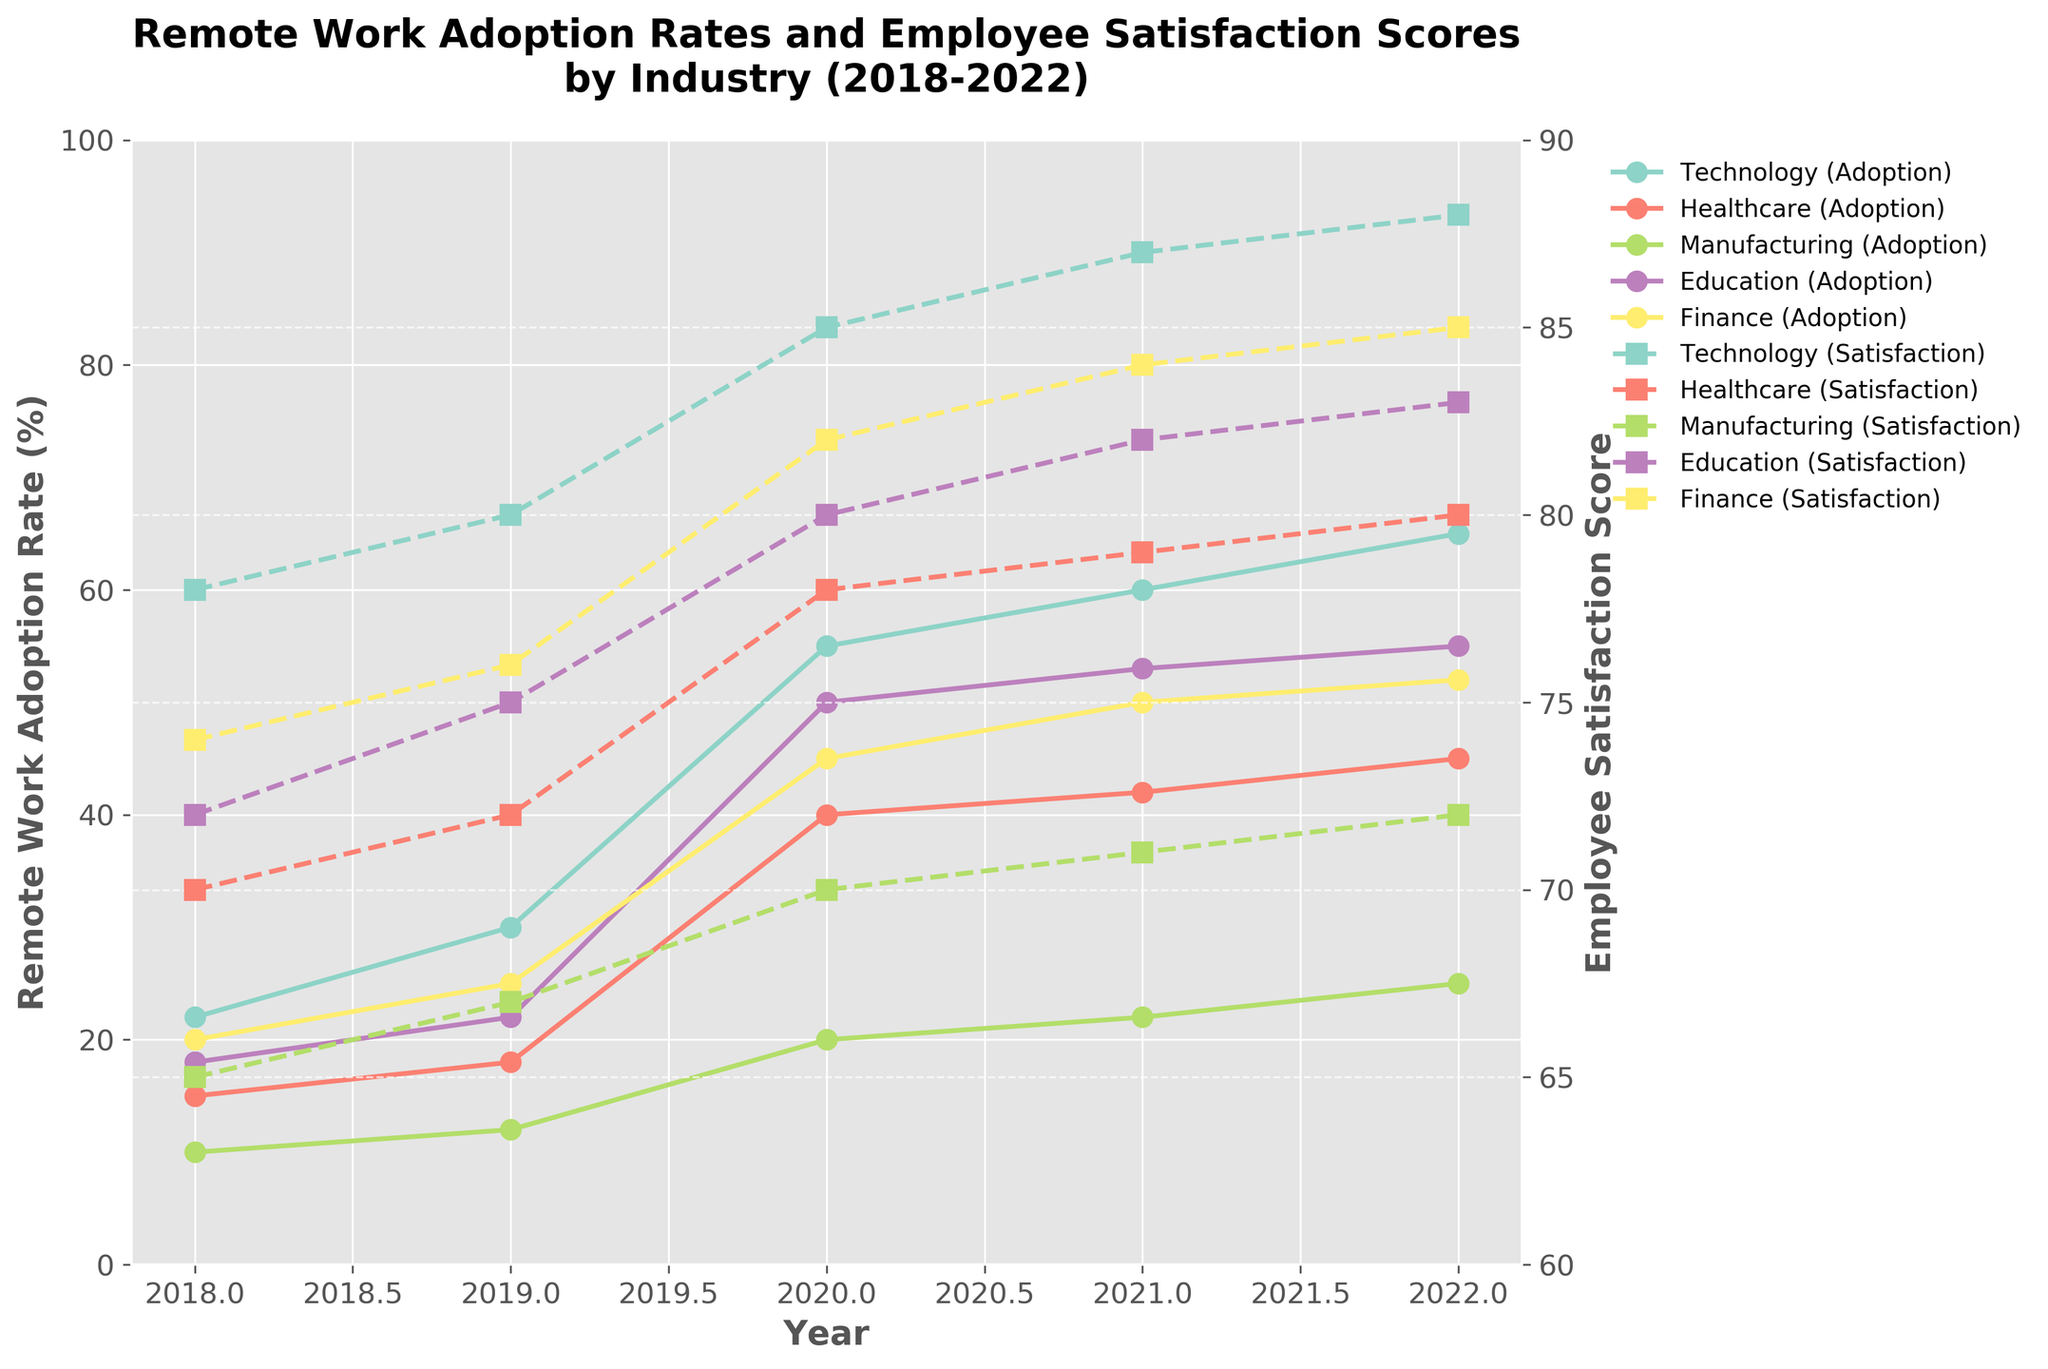What is the trend of remote work adoption in the Technology industry from 2018 to 2022? As we observe the plot, the remote work adoption rate in the Technology industry increases every year from 22% in 2018 to 65% in 2022.
Answer: Increasing What is the highest employee satisfaction score recorded, and in which industry and year did it occur? The highest employee satisfaction score on the plot is 88, recorded in the Technology industry in the year 2022.
Answer: 88, Technology, 2022 Which industry had the lowest remote work adoption rate in 2020? By examining the remote work adoption rates for 2020, it is evident that the Manufacturing industry had the lowest adoption rate of 20%.
Answer: Manufacturing How does the employee satisfaction score for the Healthcare industry in 2021 compare to that in 2019? In 2021, the Healthcare industry had a satisfaction score of 79, while in 2019 it was 72, indicating an increase of 7 points.
Answer: Increased by 7 points Compare the remote work adoption rate and employee satisfaction score for the Finance industry between 2018 and 2022. The remote work adoption in the Finance industry increased from 20% in 2018 to 52% in 2022, and the employee satisfaction score rose from 74 to 85 during the same period.
Answer: Adoption rate increased by 32%, satisfaction score increased by 11 points Which industry shows the most significant increase in remote work adoption rate between 2019 and 2020? Analyzing the adoption rates, the Technology industry shows the most significant increase from 30% in 2019 to 55% in 2020, a rise of 25 percentage points.
Answer: Technology, 25 percentage points What is the general relationship between remote work adoption rates and employee satisfaction scores across industries? Observing the plot, as the remote work adoption rates increase, the employee satisfaction scores also tend to increase across all industries.
Answer: Positive correlation Which industry had a lower remote work adoption rate than the Education industry in 2021? From the 2021 data on the plot, Manufacturing had a lower remote work adoption rate (22%) compared to Education (53%).
Answer: Manufacturing Did any industry’s employee satisfaction score decrease between 2021 and 2022? Upon examining the plot, none of the industries experienced a decrease in employee satisfaction scores between 2021 and 2022; all scores either increased or remained constant.
Answer: No 